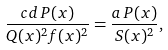<formula> <loc_0><loc_0><loc_500><loc_500>\frac { c d \, P ( x ) } { Q ( x ) ^ { 2 } f ( x ) ^ { 2 } } = \frac { a \, P ( x ) } { S ( x ) ^ { 2 } } ,</formula> 